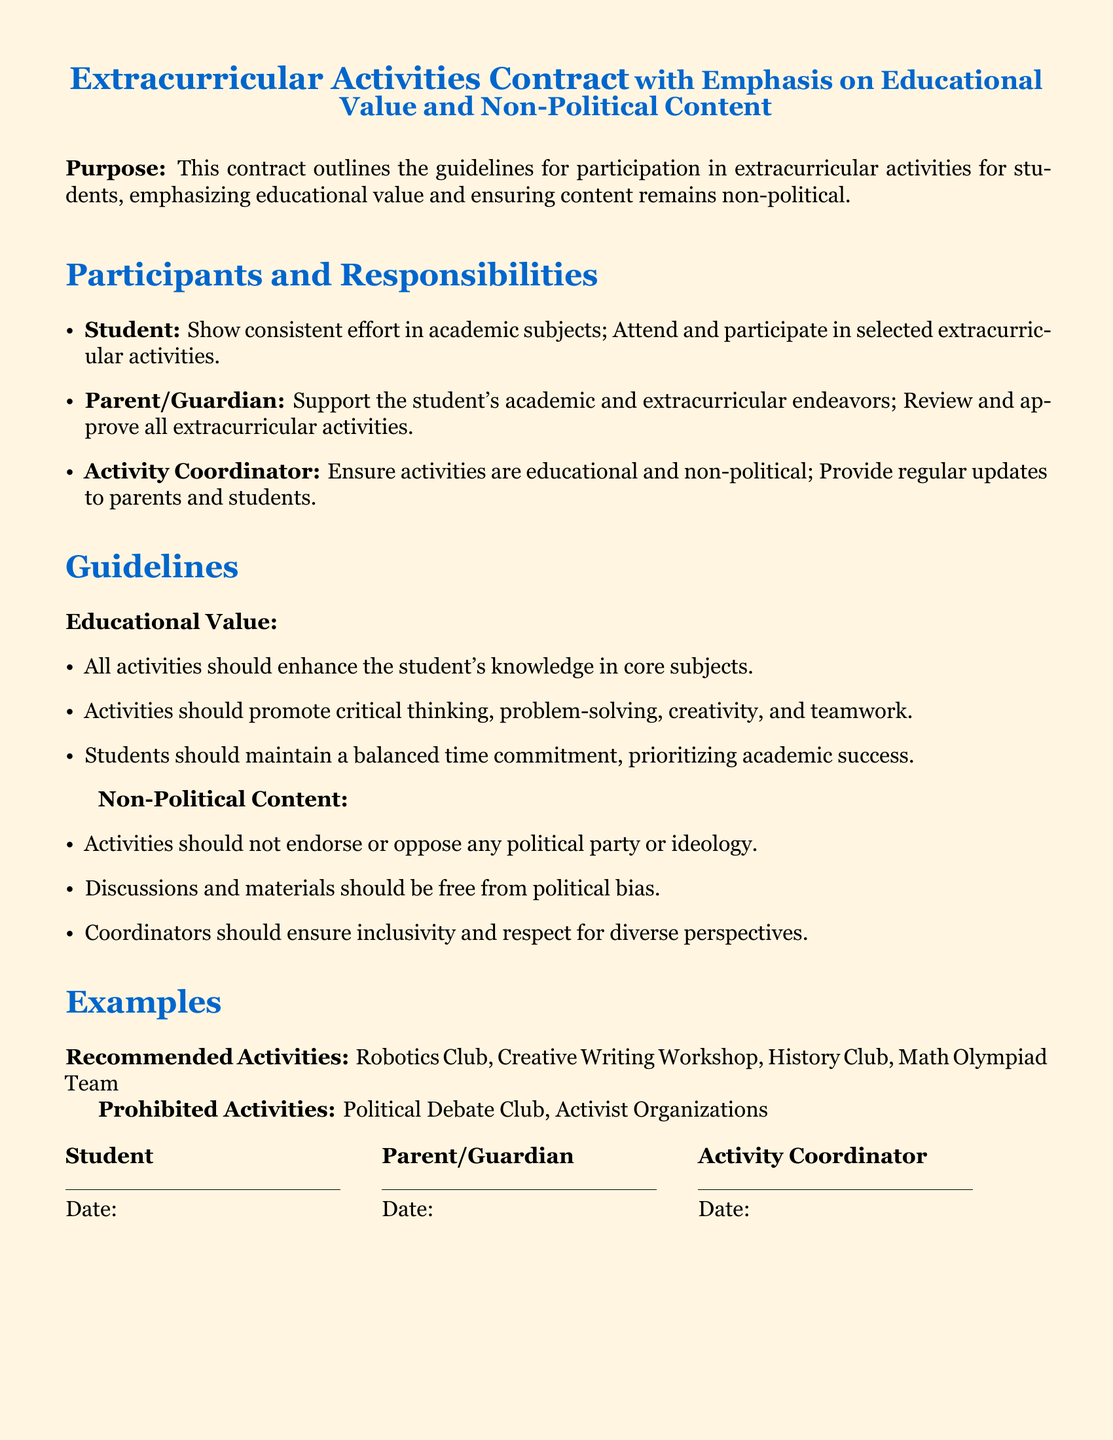What is the title of the document? The title provides a clear indication of the purpose and content of the document. It is "Extracurricular Activities Contract with Emphasis on Educational Value and Non-Political Content."
Answer: Extracurricular Activities Contract with Emphasis on Educational Value and Non-Political Content Who is responsible for updating parents and students? This question refers to the designated role outlined in the contract for overseeing communication. The activity coordinator is responsible for this task.
Answer: Activity Coordinator What type of activities are prohibited? The question focuses on determining activities that are not allowed as per the guidelines. The document lists specific types of activities that do not align with its purpose.
Answer: Political Debate Club, Activist Organizations What should all activities enhance? This question pertains to the overall goal of the activities as specified in the guidelines section. The aim is to improve students' educational experiences.
Answer: Student's knowledge in core subjects What must parents do regarding extracurricular activities? This asks for parental involvement as specified in their section of the responsibilities, emphasizing their role in ensuring alignment with educational values.
Answer: Review and approve all extracurricular activities How should discussions and materials be regarding political content? This question addresses how discussions and materials are to be approached to fulfill the non-political requirement stated in the guidelines.
Answer: Free from political bias List one recommended activity mentioned in the document. This question requests a specific example of an activity that aligns with the contract’s educational value focus.
Answer: Robotics Club 